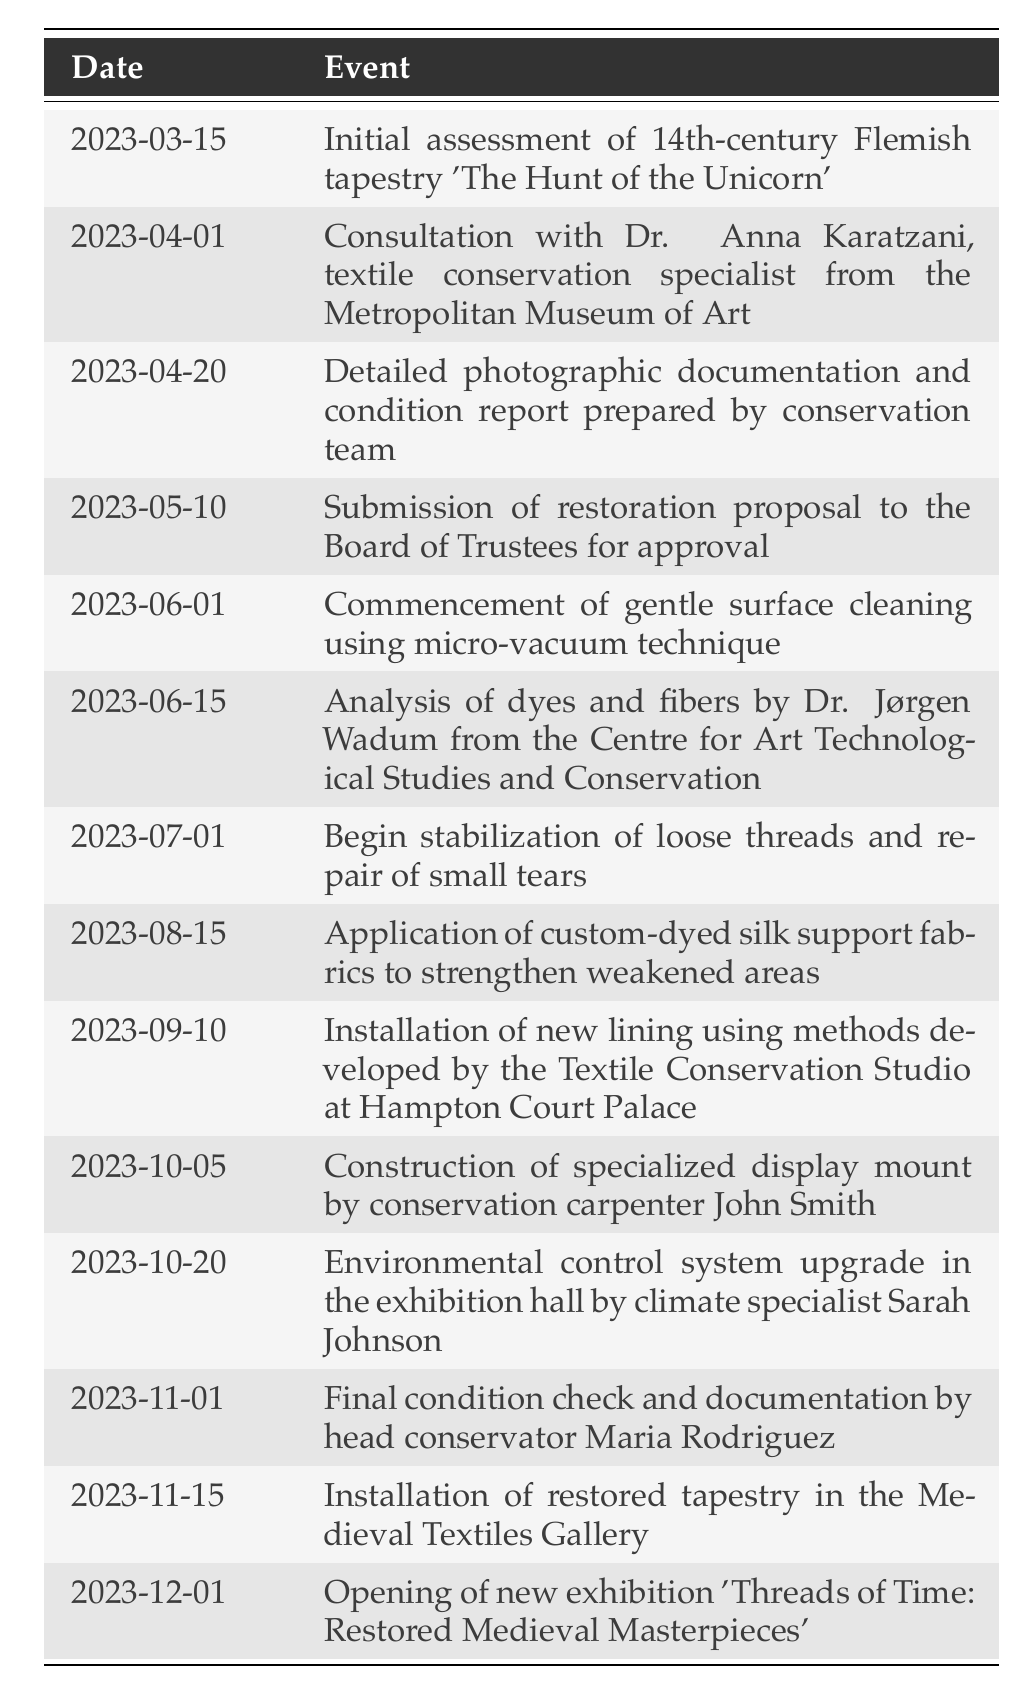What was the date of the initial assessment of the tapestry? The first event in the timeline is the initial assessment which occurred on March 15, 2023. This date is listed directly in the table.
Answer: March 15, 2023 Who consulted with the textile conservation specialist? The timeline shows that on April 1, 2023, there was a consultation with Dr. Anna Karatzani from the Metropolitan Museum of Art. Therefore, Dr. Anna Karatzani is the specialist referred to in the question.
Answer: Dr. Anna Karatzani How many months were there between the commencement of surface cleaning and the installation of the restored tapestry? The surface cleaning started on June 1, 2023, and the installation of the restored tapestry occurred on November 15, 2023. The months between June and November are five months.
Answer: 5 months Was a condition report prepared by the conservation team? Yes, the timeline indicates that a detailed photographic documentation and condition report was prepared by the conservation team on April 20, 2023.
Answer: Yes What event occurred right before the opening of the exhibition? According to the timeline, the installation of the restored tapestry took place on November 15, 2023, and the exhibition opened shortly after on December 1, 2023. Thus, the event that occurred immediately before the exhibition opening is the installation of the restored tapestry.
Answer: Installation of restored tapestry How long was the period between the final condition check and the restoration proposal submission? The final condition check occurred on November 1, 2023, and the restoration proposal was submitted on May 10, 2023. Counting from May 10 to November 1 involves six months and 22 days. Therefore, the duration between these two events is approximately six months and three weeks.
Answer: About six months and three weeks Was the environmental control system upgrade done by the textile conservation studio? No, the environmental control system upgrade was performed by climate specialist Sarah Johnson, not by the Textile Conservation Studio.
Answer: No What was the last event listed in the restoration project timeline? The last event in the timeline shows that the opening of the new exhibition titled 'Threads of Time: Restored Medieval Masterpieces' took place on December 1, 2023. This information is found at the bottom of the table.
Answer: Opening of new exhibition 